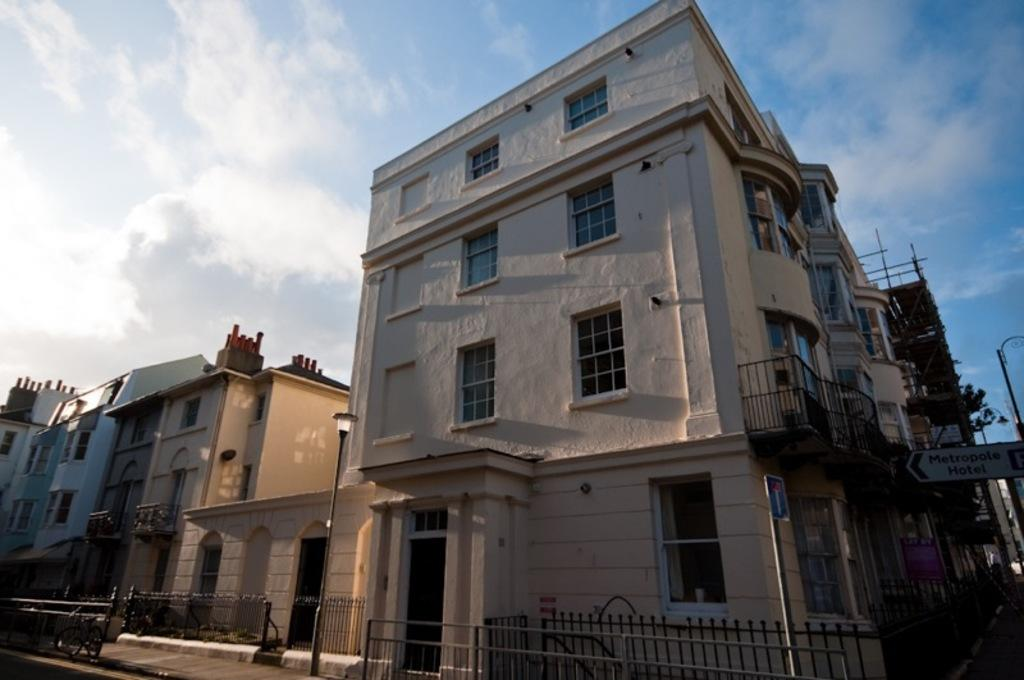What type of structures can be seen in the image? There are buildings in the image. What materials are used in the construction of these structures? Metal rods are present in the image, which may be part of the construction. What other objects can be seen in the image? Poles and fences are visible in the image. What is visible in the sky-wise in the image? Clouds are present in the image. How many frogs are sitting on the can in the image? There are no frogs or cans present in the image. Is there a book lying on the ground in the image? There is no book visible in the image. 